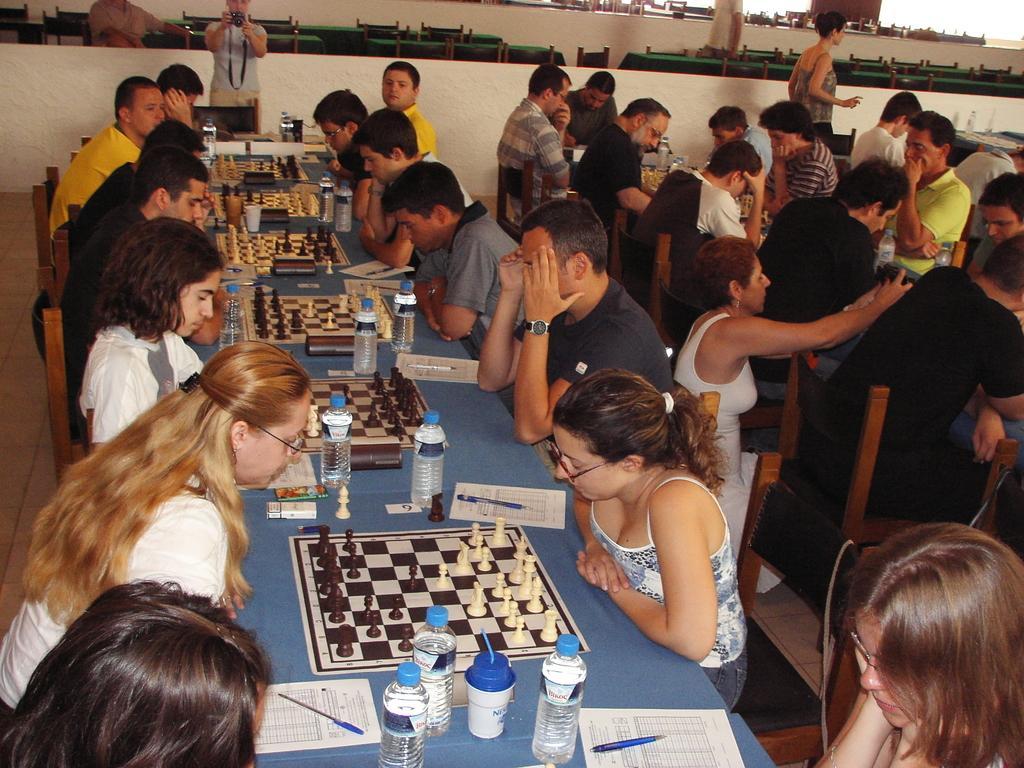Describe this image in one or two sentences. In this image there are group of persons playing chess and at the top of the image there is a photographer who is taking photographs. 